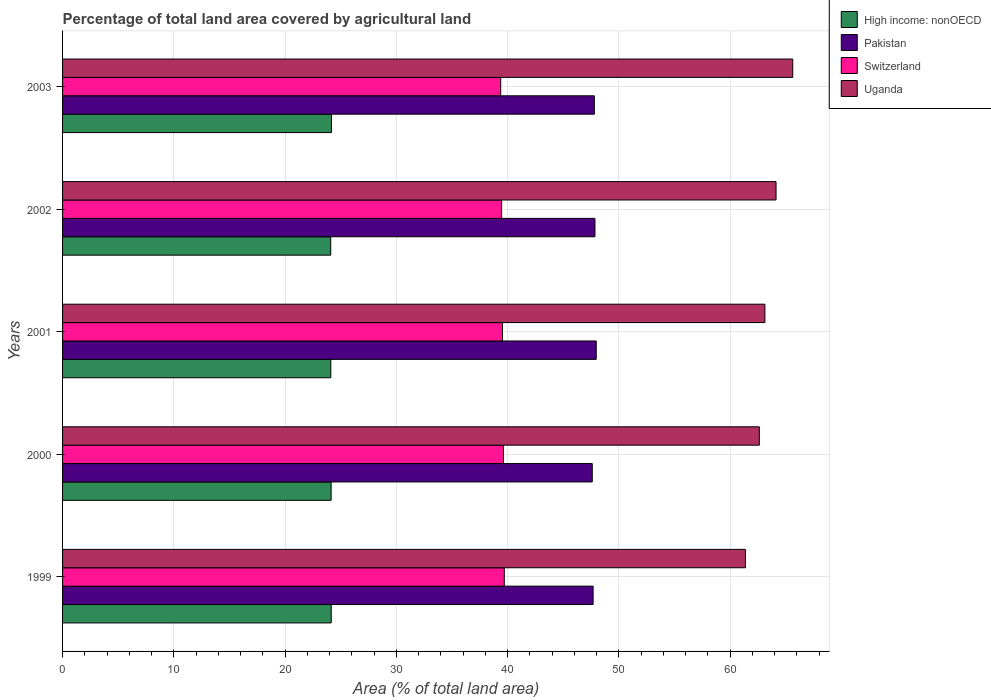How many different coloured bars are there?
Offer a terse response. 4. Are the number of bars on each tick of the Y-axis equal?
Offer a very short reply. Yes. How many bars are there on the 5th tick from the top?
Give a very brief answer. 4. How many bars are there on the 1st tick from the bottom?
Your answer should be compact. 4. What is the label of the 1st group of bars from the top?
Offer a very short reply. 2003. What is the percentage of agricultural land in Pakistan in 2003?
Your answer should be very brief. 47.79. Across all years, what is the maximum percentage of agricultural land in Pakistan?
Your answer should be very brief. 47.96. Across all years, what is the minimum percentage of agricultural land in Pakistan?
Your answer should be very brief. 47.61. In which year was the percentage of agricultural land in Uganda maximum?
Keep it short and to the point. 2003. In which year was the percentage of agricultural land in Pakistan minimum?
Your answer should be compact. 2000. What is the total percentage of agricultural land in High income: nonOECD in the graph?
Provide a short and direct response. 120.65. What is the difference between the percentage of agricultural land in Switzerland in 1999 and that in 2002?
Give a very brief answer. 0.24. What is the difference between the percentage of agricultural land in Uganda in 1999 and the percentage of agricultural land in High income: nonOECD in 2001?
Your answer should be compact. 37.26. What is the average percentage of agricultural land in Uganda per year?
Keep it short and to the point. 63.37. In the year 2003, what is the difference between the percentage of agricultural land in Uganda and percentage of agricultural land in Switzerland?
Provide a short and direct response. 26.25. What is the ratio of the percentage of agricultural land in Switzerland in 2000 to that in 2001?
Provide a succinct answer. 1. What is the difference between the highest and the second highest percentage of agricultural land in Switzerland?
Keep it short and to the point. 0.08. What is the difference between the highest and the lowest percentage of agricultural land in Pakistan?
Give a very brief answer. 0.36. In how many years, is the percentage of agricultural land in Pakistan greater than the average percentage of agricultural land in Pakistan taken over all years?
Make the answer very short. 3. What does the 4th bar from the top in 1999 represents?
Your response must be concise. High income: nonOECD. What does the 1st bar from the bottom in 2002 represents?
Ensure brevity in your answer.  High income: nonOECD. How many bars are there?
Your answer should be compact. 20. Are all the bars in the graph horizontal?
Ensure brevity in your answer.  Yes. Where does the legend appear in the graph?
Your response must be concise. Top right. What is the title of the graph?
Your answer should be compact. Percentage of total land area covered by agricultural land. What is the label or title of the X-axis?
Make the answer very short. Area (% of total land area). What is the label or title of the Y-axis?
Ensure brevity in your answer.  Years. What is the Area (% of total land area) in High income: nonOECD in 1999?
Provide a short and direct response. 24.14. What is the Area (% of total land area) in Pakistan in 1999?
Your response must be concise. 47.68. What is the Area (% of total land area) in Switzerland in 1999?
Give a very brief answer. 39.7. What is the Area (% of total land area) in Uganda in 1999?
Ensure brevity in your answer.  61.37. What is the Area (% of total land area) of High income: nonOECD in 2000?
Ensure brevity in your answer.  24.14. What is the Area (% of total land area) of Pakistan in 2000?
Your answer should be compact. 47.61. What is the Area (% of total land area) of Switzerland in 2000?
Make the answer very short. 39.62. What is the Area (% of total land area) in Uganda in 2000?
Offer a very short reply. 62.62. What is the Area (% of total land area) in High income: nonOECD in 2001?
Provide a succinct answer. 24.11. What is the Area (% of total land area) in Pakistan in 2001?
Give a very brief answer. 47.96. What is the Area (% of total land area) in Switzerland in 2001?
Keep it short and to the point. 39.54. What is the Area (% of total land area) in Uganda in 2001?
Keep it short and to the point. 63.12. What is the Area (% of total land area) of High income: nonOECD in 2002?
Your response must be concise. 24.1. What is the Area (% of total land area) of Pakistan in 2002?
Your answer should be compact. 47.85. What is the Area (% of total land area) in Switzerland in 2002?
Your answer should be compact. 39.46. What is the Area (% of total land area) of Uganda in 2002?
Offer a terse response. 64.12. What is the Area (% of total land area) in High income: nonOECD in 2003?
Ensure brevity in your answer.  24.17. What is the Area (% of total land area) in Pakistan in 2003?
Your response must be concise. 47.79. What is the Area (% of total land area) in Switzerland in 2003?
Provide a short and direct response. 39.38. What is the Area (% of total land area) of Uganda in 2003?
Your response must be concise. 65.62. Across all years, what is the maximum Area (% of total land area) in High income: nonOECD?
Ensure brevity in your answer.  24.17. Across all years, what is the maximum Area (% of total land area) in Pakistan?
Ensure brevity in your answer.  47.96. Across all years, what is the maximum Area (% of total land area) of Switzerland?
Give a very brief answer. 39.7. Across all years, what is the maximum Area (% of total land area) of Uganda?
Make the answer very short. 65.62. Across all years, what is the minimum Area (% of total land area) in High income: nonOECD?
Provide a succinct answer. 24.1. Across all years, what is the minimum Area (% of total land area) in Pakistan?
Give a very brief answer. 47.61. Across all years, what is the minimum Area (% of total land area) of Switzerland?
Your response must be concise. 39.38. Across all years, what is the minimum Area (% of total land area) of Uganda?
Give a very brief answer. 61.37. What is the total Area (% of total land area) of High income: nonOECD in the graph?
Provide a succinct answer. 120.65. What is the total Area (% of total land area) of Pakistan in the graph?
Ensure brevity in your answer.  238.89. What is the total Area (% of total land area) in Switzerland in the graph?
Make the answer very short. 197.69. What is the total Area (% of total land area) of Uganda in the graph?
Keep it short and to the point. 316.85. What is the difference between the Area (% of total land area) of High income: nonOECD in 1999 and that in 2000?
Your response must be concise. 0.01. What is the difference between the Area (% of total land area) in Pakistan in 1999 and that in 2000?
Keep it short and to the point. 0.08. What is the difference between the Area (% of total land area) of Switzerland in 1999 and that in 2000?
Give a very brief answer. 0.08. What is the difference between the Area (% of total land area) in Uganda in 1999 and that in 2000?
Your answer should be compact. -1.25. What is the difference between the Area (% of total land area) in High income: nonOECD in 1999 and that in 2001?
Your answer should be very brief. 0.04. What is the difference between the Area (% of total land area) in Pakistan in 1999 and that in 2001?
Offer a very short reply. -0.28. What is the difference between the Area (% of total land area) in Switzerland in 1999 and that in 2001?
Your answer should be compact. 0.16. What is the difference between the Area (% of total land area) in Uganda in 1999 and that in 2001?
Ensure brevity in your answer.  -1.75. What is the difference between the Area (% of total land area) of High income: nonOECD in 1999 and that in 2002?
Ensure brevity in your answer.  0.05. What is the difference between the Area (% of total land area) in Pakistan in 1999 and that in 2002?
Give a very brief answer. -0.17. What is the difference between the Area (% of total land area) of Switzerland in 1999 and that in 2002?
Your answer should be compact. 0.24. What is the difference between the Area (% of total land area) in Uganda in 1999 and that in 2002?
Your response must be concise. -2.75. What is the difference between the Area (% of total land area) of High income: nonOECD in 1999 and that in 2003?
Your answer should be compact. -0.02. What is the difference between the Area (% of total land area) of Pakistan in 1999 and that in 2003?
Your response must be concise. -0.11. What is the difference between the Area (% of total land area) in Switzerland in 1999 and that in 2003?
Provide a short and direct response. 0.32. What is the difference between the Area (% of total land area) of Uganda in 1999 and that in 2003?
Give a very brief answer. -4.25. What is the difference between the Area (% of total land area) of High income: nonOECD in 2000 and that in 2001?
Your answer should be very brief. 0.03. What is the difference between the Area (% of total land area) in Pakistan in 2000 and that in 2001?
Give a very brief answer. -0.36. What is the difference between the Area (% of total land area) in Switzerland in 2000 and that in 2001?
Your response must be concise. 0.09. What is the difference between the Area (% of total land area) in Uganda in 2000 and that in 2001?
Ensure brevity in your answer.  -0.5. What is the difference between the Area (% of total land area) in High income: nonOECD in 2000 and that in 2002?
Offer a very short reply. 0.04. What is the difference between the Area (% of total land area) of Pakistan in 2000 and that in 2002?
Your answer should be compact. -0.24. What is the difference between the Area (% of total land area) of Switzerland in 2000 and that in 2002?
Make the answer very short. 0.16. What is the difference between the Area (% of total land area) of Uganda in 2000 and that in 2002?
Keep it short and to the point. -1.5. What is the difference between the Area (% of total land area) in High income: nonOECD in 2000 and that in 2003?
Your response must be concise. -0.03. What is the difference between the Area (% of total land area) in Pakistan in 2000 and that in 2003?
Give a very brief answer. -0.19. What is the difference between the Area (% of total land area) of Switzerland in 2000 and that in 2003?
Make the answer very short. 0.24. What is the difference between the Area (% of total land area) of Uganda in 2000 and that in 2003?
Provide a short and direct response. -3. What is the difference between the Area (% of total land area) in High income: nonOECD in 2001 and that in 2002?
Give a very brief answer. 0.01. What is the difference between the Area (% of total land area) in Pakistan in 2001 and that in 2002?
Provide a succinct answer. 0.11. What is the difference between the Area (% of total land area) of Switzerland in 2001 and that in 2002?
Your answer should be very brief. 0.08. What is the difference between the Area (% of total land area) of Uganda in 2001 and that in 2002?
Ensure brevity in your answer.  -1. What is the difference between the Area (% of total land area) of High income: nonOECD in 2001 and that in 2003?
Provide a succinct answer. -0.06. What is the difference between the Area (% of total land area) in Pakistan in 2001 and that in 2003?
Offer a very short reply. 0.17. What is the difference between the Area (% of total land area) of Switzerland in 2001 and that in 2003?
Keep it short and to the point. 0.16. What is the difference between the Area (% of total land area) in Uganda in 2001 and that in 2003?
Provide a succinct answer. -2.5. What is the difference between the Area (% of total land area) in High income: nonOECD in 2002 and that in 2003?
Your response must be concise. -0.07. What is the difference between the Area (% of total land area) of Pakistan in 2002 and that in 2003?
Offer a very short reply. 0.05. What is the difference between the Area (% of total land area) of Switzerland in 2002 and that in 2003?
Your answer should be very brief. 0.08. What is the difference between the Area (% of total land area) in Uganda in 2002 and that in 2003?
Provide a succinct answer. -1.5. What is the difference between the Area (% of total land area) of High income: nonOECD in 1999 and the Area (% of total land area) of Pakistan in 2000?
Offer a very short reply. -23.46. What is the difference between the Area (% of total land area) of High income: nonOECD in 1999 and the Area (% of total land area) of Switzerland in 2000?
Your answer should be compact. -15.48. What is the difference between the Area (% of total land area) in High income: nonOECD in 1999 and the Area (% of total land area) in Uganda in 2000?
Offer a terse response. -38.47. What is the difference between the Area (% of total land area) in Pakistan in 1999 and the Area (% of total land area) in Switzerland in 2000?
Your answer should be compact. 8.06. What is the difference between the Area (% of total land area) of Pakistan in 1999 and the Area (% of total land area) of Uganda in 2000?
Provide a succinct answer. -14.94. What is the difference between the Area (% of total land area) of Switzerland in 1999 and the Area (% of total land area) of Uganda in 2000?
Provide a short and direct response. -22.92. What is the difference between the Area (% of total land area) of High income: nonOECD in 1999 and the Area (% of total land area) of Pakistan in 2001?
Provide a short and direct response. -23.82. What is the difference between the Area (% of total land area) in High income: nonOECD in 1999 and the Area (% of total land area) in Switzerland in 2001?
Keep it short and to the point. -15.39. What is the difference between the Area (% of total land area) in High income: nonOECD in 1999 and the Area (% of total land area) in Uganda in 2001?
Provide a short and direct response. -38.98. What is the difference between the Area (% of total land area) of Pakistan in 1999 and the Area (% of total land area) of Switzerland in 2001?
Keep it short and to the point. 8.14. What is the difference between the Area (% of total land area) of Pakistan in 1999 and the Area (% of total land area) of Uganda in 2001?
Provide a short and direct response. -15.44. What is the difference between the Area (% of total land area) of Switzerland in 1999 and the Area (% of total land area) of Uganda in 2001?
Ensure brevity in your answer.  -23.42. What is the difference between the Area (% of total land area) of High income: nonOECD in 1999 and the Area (% of total land area) of Pakistan in 2002?
Give a very brief answer. -23.7. What is the difference between the Area (% of total land area) in High income: nonOECD in 1999 and the Area (% of total land area) in Switzerland in 2002?
Make the answer very short. -15.31. What is the difference between the Area (% of total land area) in High income: nonOECD in 1999 and the Area (% of total land area) in Uganda in 2002?
Provide a short and direct response. -39.98. What is the difference between the Area (% of total land area) of Pakistan in 1999 and the Area (% of total land area) of Switzerland in 2002?
Your response must be concise. 8.22. What is the difference between the Area (% of total land area) in Pakistan in 1999 and the Area (% of total land area) in Uganda in 2002?
Ensure brevity in your answer.  -16.44. What is the difference between the Area (% of total land area) of Switzerland in 1999 and the Area (% of total land area) of Uganda in 2002?
Give a very brief answer. -24.42. What is the difference between the Area (% of total land area) of High income: nonOECD in 1999 and the Area (% of total land area) of Pakistan in 2003?
Your answer should be very brief. -23.65. What is the difference between the Area (% of total land area) in High income: nonOECD in 1999 and the Area (% of total land area) in Switzerland in 2003?
Keep it short and to the point. -15.23. What is the difference between the Area (% of total land area) in High income: nonOECD in 1999 and the Area (% of total land area) in Uganda in 2003?
Offer a very short reply. -41.48. What is the difference between the Area (% of total land area) in Pakistan in 1999 and the Area (% of total land area) in Switzerland in 2003?
Your answer should be very brief. 8.3. What is the difference between the Area (% of total land area) of Pakistan in 1999 and the Area (% of total land area) of Uganda in 2003?
Keep it short and to the point. -17.94. What is the difference between the Area (% of total land area) of Switzerland in 1999 and the Area (% of total land area) of Uganda in 2003?
Provide a succinct answer. -25.92. What is the difference between the Area (% of total land area) of High income: nonOECD in 2000 and the Area (% of total land area) of Pakistan in 2001?
Keep it short and to the point. -23.82. What is the difference between the Area (% of total land area) of High income: nonOECD in 2000 and the Area (% of total land area) of Switzerland in 2001?
Your answer should be very brief. -15.4. What is the difference between the Area (% of total land area) in High income: nonOECD in 2000 and the Area (% of total land area) in Uganda in 2001?
Make the answer very short. -38.98. What is the difference between the Area (% of total land area) of Pakistan in 2000 and the Area (% of total land area) of Switzerland in 2001?
Make the answer very short. 8.07. What is the difference between the Area (% of total land area) of Pakistan in 2000 and the Area (% of total land area) of Uganda in 2001?
Provide a short and direct response. -15.51. What is the difference between the Area (% of total land area) of Switzerland in 2000 and the Area (% of total land area) of Uganda in 2001?
Provide a succinct answer. -23.5. What is the difference between the Area (% of total land area) of High income: nonOECD in 2000 and the Area (% of total land area) of Pakistan in 2002?
Ensure brevity in your answer.  -23.71. What is the difference between the Area (% of total land area) in High income: nonOECD in 2000 and the Area (% of total land area) in Switzerland in 2002?
Offer a very short reply. -15.32. What is the difference between the Area (% of total land area) in High income: nonOECD in 2000 and the Area (% of total land area) in Uganda in 2002?
Offer a very short reply. -39.98. What is the difference between the Area (% of total land area) of Pakistan in 2000 and the Area (% of total land area) of Switzerland in 2002?
Ensure brevity in your answer.  8.15. What is the difference between the Area (% of total land area) of Pakistan in 2000 and the Area (% of total land area) of Uganda in 2002?
Offer a terse response. -16.52. What is the difference between the Area (% of total land area) of Switzerland in 2000 and the Area (% of total land area) of Uganda in 2002?
Make the answer very short. -24.5. What is the difference between the Area (% of total land area) of High income: nonOECD in 2000 and the Area (% of total land area) of Pakistan in 2003?
Offer a terse response. -23.66. What is the difference between the Area (% of total land area) in High income: nonOECD in 2000 and the Area (% of total land area) in Switzerland in 2003?
Your answer should be very brief. -15.24. What is the difference between the Area (% of total land area) of High income: nonOECD in 2000 and the Area (% of total land area) of Uganda in 2003?
Your response must be concise. -41.49. What is the difference between the Area (% of total land area) in Pakistan in 2000 and the Area (% of total land area) in Switzerland in 2003?
Your answer should be very brief. 8.23. What is the difference between the Area (% of total land area) in Pakistan in 2000 and the Area (% of total land area) in Uganda in 2003?
Your response must be concise. -18.02. What is the difference between the Area (% of total land area) in Switzerland in 2000 and the Area (% of total land area) in Uganda in 2003?
Ensure brevity in your answer.  -26. What is the difference between the Area (% of total land area) in High income: nonOECD in 2001 and the Area (% of total land area) in Pakistan in 2002?
Offer a very short reply. -23.74. What is the difference between the Area (% of total land area) of High income: nonOECD in 2001 and the Area (% of total land area) of Switzerland in 2002?
Offer a very short reply. -15.35. What is the difference between the Area (% of total land area) in High income: nonOECD in 2001 and the Area (% of total land area) in Uganda in 2002?
Your answer should be compact. -40.01. What is the difference between the Area (% of total land area) of Pakistan in 2001 and the Area (% of total land area) of Switzerland in 2002?
Give a very brief answer. 8.5. What is the difference between the Area (% of total land area) of Pakistan in 2001 and the Area (% of total land area) of Uganda in 2002?
Ensure brevity in your answer.  -16.16. What is the difference between the Area (% of total land area) of Switzerland in 2001 and the Area (% of total land area) of Uganda in 2002?
Ensure brevity in your answer.  -24.58. What is the difference between the Area (% of total land area) of High income: nonOECD in 2001 and the Area (% of total land area) of Pakistan in 2003?
Your answer should be very brief. -23.69. What is the difference between the Area (% of total land area) of High income: nonOECD in 2001 and the Area (% of total land area) of Switzerland in 2003?
Offer a terse response. -15.27. What is the difference between the Area (% of total land area) in High income: nonOECD in 2001 and the Area (% of total land area) in Uganda in 2003?
Give a very brief answer. -41.52. What is the difference between the Area (% of total land area) in Pakistan in 2001 and the Area (% of total land area) in Switzerland in 2003?
Your answer should be very brief. 8.58. What is the difference between the Area (% of total land area) of Pakistan in 2001 and the Area (% of total land area) of Uganda in 2003?
Provide a succinct answer. -17.66. What is the difference between the Area (% of total land area) in Switzerland in 2001 and the Area (% of total land area) in Uganda in 2003?
Provide a succinct answer. -26.09. What is the difference between the Area (% of total land area) of High income: nonOECD in 2002 and the Area (% of total land area) of Pakistan in 2003?
Provide a succinct answer. -23.69. What is the difference between the Area (% of total land area) in High income: nonOECD in 2002 and the Area (% of total land area) in Switzerland in 2003?
Give a very brief answer. -15.28. What is the difference between the Area (% of total land area) of High income: nonOECD in 2002 and the Area (% of total land area) of Uganda in 2003?
Your response must be concise. -41.52. What is the difference between the Area (% of total land area) in Pakistan in 2002 and the Area (% of total land area) in Switzerland in 2003?
Your answer should be very brief. 8.47. What is the difference between the Area (% of total land area) of Pakistan in 2002 and the Area (% of total land area) of Uganda in 2003?
Make the answer very short. -17.78. What is the difference between the Area (% of total land area) in Switzerland in 2002 and the Area (% of total land area) in Uganda in 2003?
Give a very brief answer. -26.16. What is the average Area (% of total land area) of High income: nonOECD per year?
Give a very brief answer. 24.13. What is the average Area (% of total land area) of Pakistan per year?
Ensure brevity in your answer.  47.78. What is the average Area (% of total land area) in Switzerland per year?
Offer a very short reply. 39.54. What is the average Area (% of total land area) of Uganda per year?
Give a very brief answer. 63.37. In the year 1999, what is the difference between the Area (% of total land area) of High income: nonOECD and Area (% of total land area) of Pakistan?
Your response must be concise. -23.54. In the year 1999, what is the difference between the Area (% of total land area) of High income: nonOECD and Area (% of total land area) of Switzerland?
Provide a succinct answer. -15.55. In the year 1999, what is the difference between the Area (% of total land area) of High income: nonOECD and Area (% of total land area) of Uganda?
Ensure brevity in your answer.  -37.22. In the year 1999, what is the difference between the Area (% of total land area) in Pakistan and Area (% of total land area) in Switzerland?
Provide a short and direct response. 7.98. In the year 1999, what is the difference between the Area (% of total land area) of Pakistan and Area (% of total land area) of Uganda?
Ensure brevity in your answer.  -13.69. In the year 1999, what is the difference between the Area (% of total land area) in Switzerland and Area (% of total land area) in Uganda?
Keep it short and to the point. -21.67. In the year 2000, what is the difference between the Area (% of total land area) of High income: nonOECD and Area (% of total land area) of Pakistan?
Keep it short and to the point. -23.47. In the year 2000, what is the difference between the Area (% of total land area) in High income: nonOECD and Area (% of total land area) in Switzerland?
Offer a very short reply. -15.49. In the year 2000, what is the difference between the Area (% of total land area) in High income: nonOECD and Area (% of total land area) in Uganda?
Offer a very short reply. -38.48. In the year 2000, what is the difference between the Area (% of total land area) in Pakistan and Area (% of total land area) in Switzerland?
Your response must be concise. 7.98. In the year 2000, what is the difference between the Area (% of total land area) of Pakistan and Area (% of total land area) of Uganda?
Provide a short and direct response. -15.01. In the year 2000, what is the difference between the Area (% of total land area) of Switzerland and Area (% of total land area) of Uganda?
Provide a succinct answer. -23. In the year 2001, what is the difference between the Area (% of total land area) of High income: nonOECD and Area (% of total land area) of Pakistan?
Give a very brief answer. -23.85. In the year 2001, what is the difference between the Area (% of total land area) of High income: nonOECD and Area (% of total land area) of Switzerland?
Your answer should be very brief. -15.43. In the year 2001, what is the difference between the Area (% of total land area) in High income: nonOECD and Area (% of total land area) in Uganda?
Ensure brevity in your answer.  -39.01. In the year 2001, what is the difference between the Area (% of total land area) of Pakistan and Area (% of total land area) of Switzerland?
Give a very brief answer. 8.42. In the year 2001, what is the difference between the Area (% of total land area) in Pakistan and Area (% of total land area) in Uganda?
Your response must be concise. -15.16. In the year 2001, what is the difference between the Area (% of total land area) in Switzerland and Area (% of total land area) in Uganda?
Your answer should be compact. -23.58. In the year 2002, what is the difference between the Area (% of total land area) of High income: nonOECD and Area (% of total land area) of Pakistan?
Give a very brief answer. -23.75. In the year 2002, what is the difference between the Area (% of total land area) in High income: nonOECD and Area (% of total land area) in Switzerland?
Provide a short and direct response. -15.36. In the year 2002, what is the difference between the Area (% of total land area) of High income: nonOECD and Area (% of total land area) of Uganda?
Give a very brief answer. -40.02. In the year 2002, what is the difference between the Area (% of total land area) in Pakistan and Area (% of total land area) in Switzerland?
Provide a short and direct response. 8.39. In the year 2002, what is the difference between the Area (% of total land area) of Pakistan and Area (% of total land area) of Uganda?
Provide a succinct answer. -16.27. In the year 2002, what is the difference between the Area (% of total land area) in Switzerland and Area (% of total land area) in Uganda?
Keep it short and to the point. -24.66. In the year 2003, what is the difference between the Area (% of total land area) in High income: nonOECD and Area (% of total land area) in Pakistan?
Offer a very short reply. -23.63. In the year 2003, what is the difference between the Area (% of total land area) of High income: nonOECD and Area (% of total land area) of Switzerland?
Provide a short and direct response. -15.21. In the year 2003, what is the difference between the Area (% of total land area) of High income: nonOECD and Area (% of total land area) of Uganda?
Keep it short and to the point. -41.46. In the year 2003, what is the difference between the Area (% of total land area) in Pakistan and Area (% of total land area) in Switzerland?
Offer a terse response. 8.42. In the year 2003, what is the difference between the Area (% of total land area) in Pakistan and Area (% of total land area) in Uganda?
Offer a terse response. -17.83. In the year 2003, what is the difference between the Area (% of total land area) in Switzerland and Area (% of total land area) in Uganda?
Keep it short and to the point. -26.25. What is the ratio of the Area (% of total land area) of Uganda in 1999 to that in 2000?
Keep it short and to the point. 0.98. What is the ratio of the Area (% of total land area) of High income: nonOECD in 1999 to that in 2001?
Provide a succinct answer. 1. What is the ratio of the Area (% of total land area) in Pakistan in 1999 to that in 2001?
Your response must be concise. 0.99. What is the ratio of the Area (% of total land area) in Uganda in 1999 to that in 2001?
Your answer should be very brief. 0.97. What is the ratio of the Area (% of total land area) in Switzerland in 1999 to that in 2002?
Keep it short and to the point. 1.01. What is the ratio of the Area (% of total land area) of Uganda in 1999 to that in 2002?
Offer a very short reply. 0.96. What is the ratio of the Area (% of total land area) in High income: nonOECD in 1999 to that in 2003?
Make the answer very short. 1. What is the ratio of the Area (% of total land area) in Pakistan in 1999 to that in 2003?
Keep it short and to the point. 1. What is the ratio of the Area (% of total land area) of Switzerland in 1999 to that in 2003?
Your response must be concise. 1.01. What is the ratio of the Area (% of total land area) in Uganda in 1999 to that in 2003?
Offer a very short reply. 0.94. What is the ratio of the Area (% of total land area) in High income: nonOECD in 2000 to that in 2001?
Give a very brief answer. 1. What is the ratio of the Area (% of total land area) of Pakistan in 2000 to that in 2001?
Your answer should be compact. 0.99. What is the ratio of the Area (% of total land area) in Switzerland in 2000 to that in 2001?
Give a very brief answer. 1. What is the ratio of the Area (% of total land area) in High income: nonOECD in 2000 to that in 2002?
Offer a terse response. 1. What is the ratio of the Area (% of total land area) of Switzerland in 2000 to that in 2002?
Ensure brevity in your answer.  1. What is the ratio of the Area (% of total land area) in Uganda in 2000 to that in 2002?
Your answer should be compact. 0.98. What is the ratio of the Area (% of total land area) in High income: nonOECD in 2000 to that in 2003?
Offer a very short reply. 1. What is the ratio of the Area (% of total land area) of Switzerland in 2000 to that in 2003?
Make the answer very short. 1.01. What is the ratio of the Area (% of total land area) in Uganda in 2000 to that in 2003?
Offer a very short reply. 0.95. What is the ratio of the Area (% of total land area) of High income: nonOECD in 2001 to that in 2002?
Your answer should be very brief. 1. What is the ratio of the Area (% of total land area) of Pakistan in 2001 to that in 2002?
Provide a short and direct response. 1. What is the ratio of the Area (% of total land area) of Switzerland in 2001 to that in 2002?
Make the answer very short. 1. What is the ratio of the Area (% of total land area) of Uganda in 2001 to that in 2002?
Provide a short and direct response. 0.98. What is the ratio of the Area (% of total land area) of High income: nonOECD in 2001 to that in 2003?
Offer a terse response. 1. What is the ratio of the Area (% of total land area) in Pakistan in 2001 to that in 2003?
Ensure brevity in your answer.  1. What is the ratio of the Area (% of total land area) of Uganda in 2001 to that in 2003?
Keep it short and to the point. 0.96. What is the ratio of the Area (% of total land area) in High income: nonOECD in 2002 to that in 2003?
Provide a succinct answer. 1. What is the ratio of the Area (% of total land area) of Pakistan in 2002 to that in 2003?
Offer a very short reply. 1. What is the ratio of the Area (% of total land area) of Switzerland in 2002 to that in 2003?
Give a very brief answer. 1. What is the ratio of the Area (% of total land area) of Uganda in 2002 to that in 2003?
Provide a short and direct response. 0.98. What is the difference between the highest and the second highest Area (% of total land area) of High income: nonOECD?
Provide a succinct answer. 0.02. What is the difference between the highest and the second highest Area (% of total land area) in Pakistan?
Ensure brevity in your answer.  0.11. What is the difference between the highest and the second highest Area (% of total land area) in Switzerland?
Provide a succinct answer. 0.08. What is the difference between the highest and the second highest Area (% of total land area) in Uganda?
Your answer should be very brief. 1.5. What is the difference between the highest and the lowest Area (% of total land area) of High income: nonOECD?
Offer a terse response. 0.07. What is the difference between the highest and the lowest Area (% of total land area) in Pakistan?
Make the answer very short. 0.36. What is the difference between the highest and the lowest Area (% of total land area) in Switzerland?
Give a very brief answer. 0.32. What is the difference between the highest and the lowest Area (% of total land area) of Uganda?
Your answer should be compact. 4.25. 